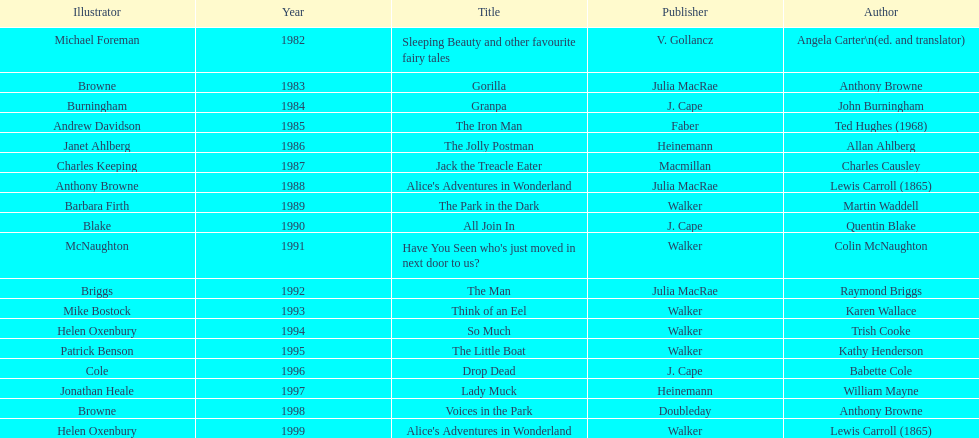Which illustrator was responsible for the last award winner? Helen Oxenbury. 